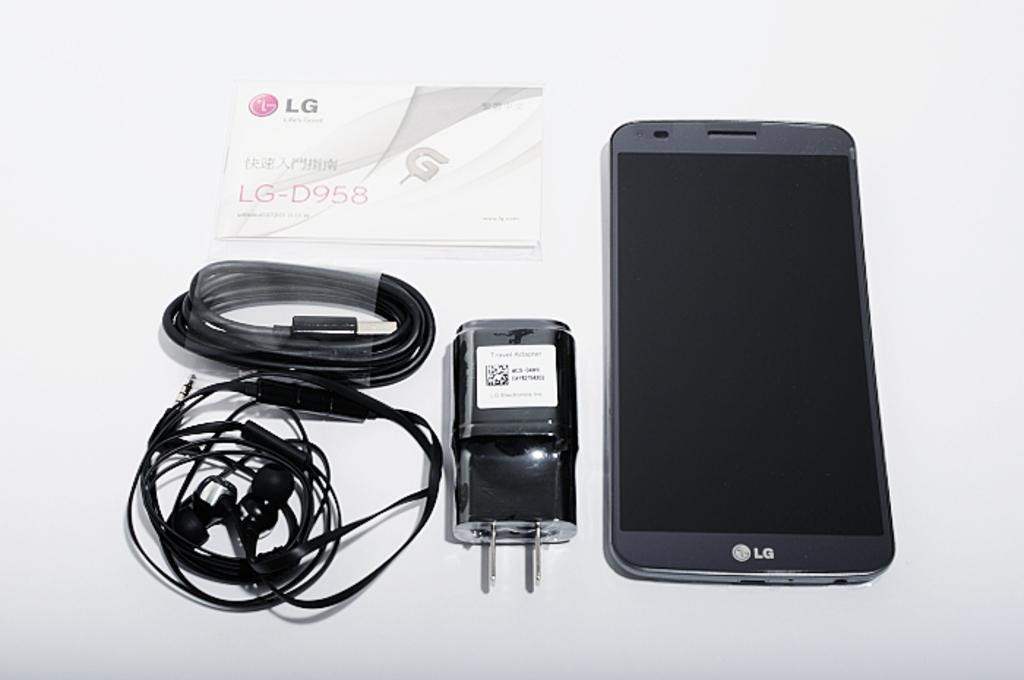<image>
Share a concise interpretation of the image provided. An LG smartphone next to a charger and headphones on a white table. 